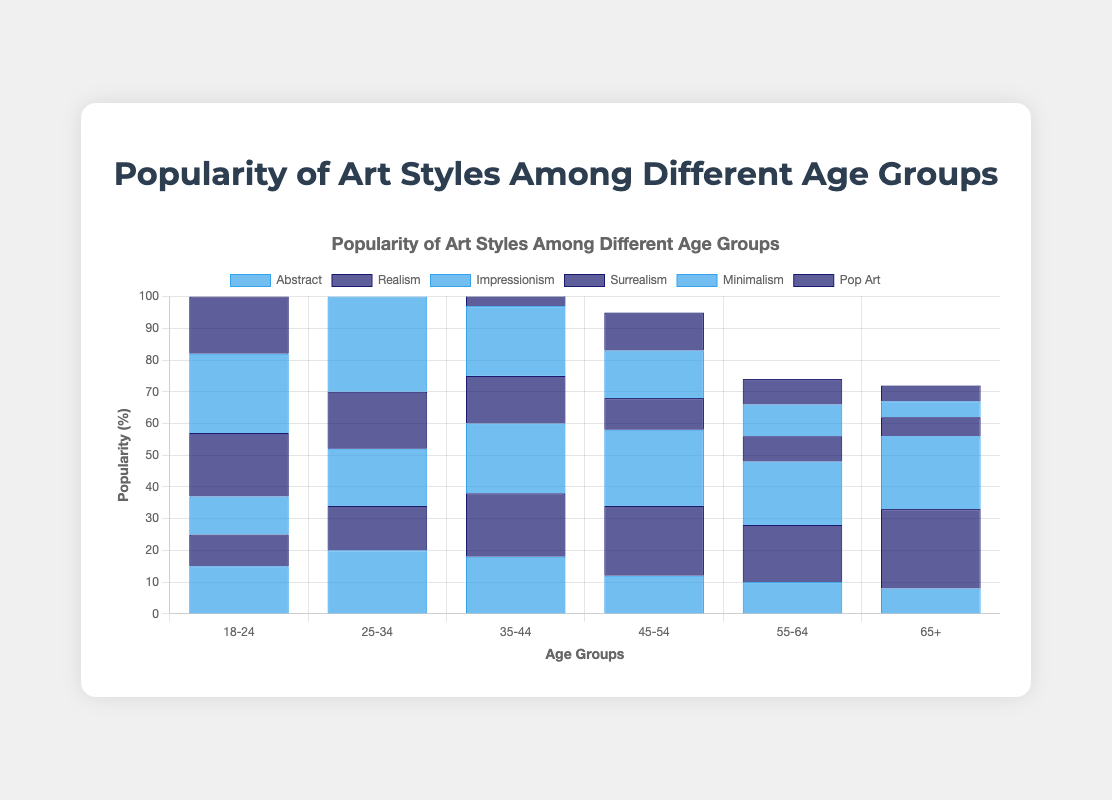Which age group has the highest preference for Abstract art? By examining the height of the bars representing Abstract art across different age groups, the highest bar corresponds to the 25-34 age group.
Answer: 25-34 Which art style is most popular among the 18-24 age group? For the 18-24 age group, the tallest bar represents Minimalism, indicating it is the most popular art style among this age group.
Answer: Minimalism Compare the popularity of Realism and Impressionism among the 45-54 age group. Which is more popular? Observing the bars for the 45-54 age group, the bar for Impressionism is taller than the bar for Realism, indicating Impressionism is more popular.
Answer: Impressionism By how much does the popularity of Surrealism decline from the 18-24 age group to the 65+ age group? The height of the Surrealism bar is 20% for the 18-24 age group and 6% for the 65+ age group. Calculating the difference: 20% - 6% = 14%.
Answer: 14% What is the total popularity of Minimalism across all age groups? Adding the bar values for Minimalism across all age groups: 25 + 30 + 22 + 15 + 10 + 5 = 107%.
Answer: 107% Is the popularity of Pop Art more consistent across age groups compared to Surrealism? The bars for Pop Art show values (18, 22, 18, 12, 8, 5), indicating less variance compared to Surrealism (20, 18, 15, 10, 8, 6). Surrealism shows a steeper decline, while Pop Art values are more evenly distributed.
Answer: Yes For the 55-64 age group, which art style is least popular? Among the bars for the 55-64 age group, the shortest bar represents Minimalism, indicating it is the least popular art style within this age group.
Answer: Minimalism How does the preference for Abstract art compare between the 25-34 and 45-54 age groups? The bar for Abstract art is higher for the 25-34 age group (20%) compared to the 45-54 age group (12%), indicating a higher preference in the former.
Answer: 25-34 Which art style's popularity remains above 20% for three consecutive age groups? Examining bar heights, Impressionism remains above 20% for the age groups 35-44, 45-54, and 55-64.
Answer: Impressionism 